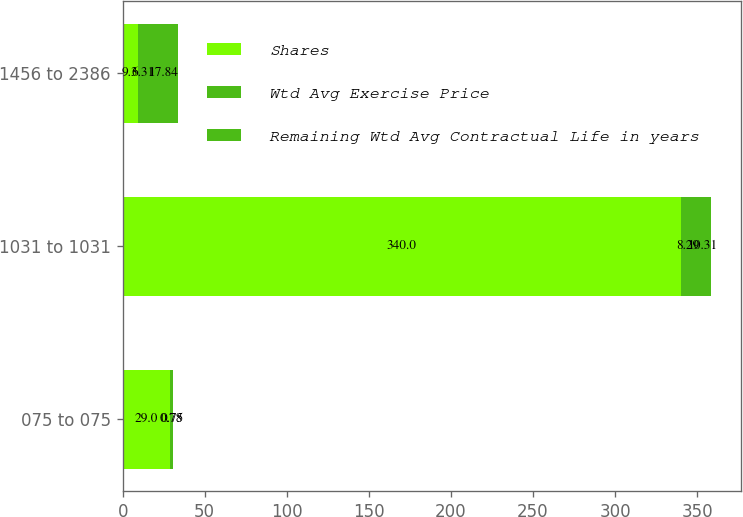Convert chart. <chart><loc_0><loc_0><loc_500><loc_500><stacked_bar_chart><ecel><fcel>075 to 075<fcel>1031 to 1031<fcel>1456 to 2386<nl><fcel>Shares<fcel>29<fcel>340<fcel>9.3<nl><fcel>Wtd Avg Exercise Price<fcel>0.78<fcel>8.29<fcel>6.31<nl><fcel>Remaining Wtd Avg Contractual Life in years<fcel>0.75<fcel>10.31<fcel>17.84<nl></chart> 